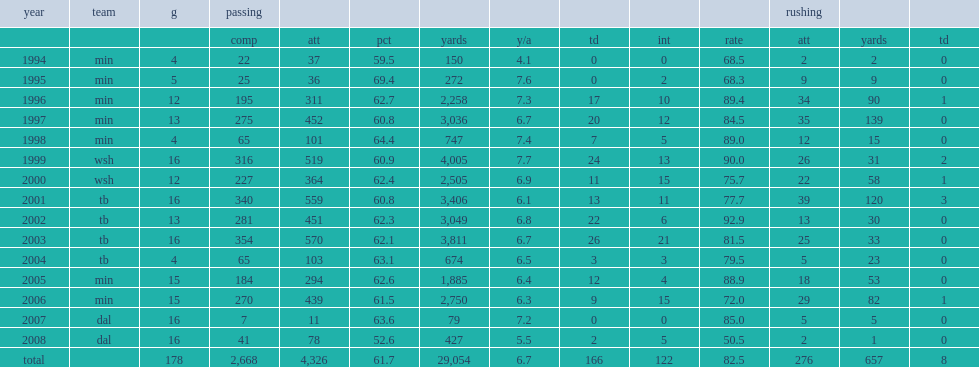How many touchdown passes did johnson finish with in 1997? 20.0. Johnson finished 1997 with 3,036 passing yards in 1997. 3036.0. 